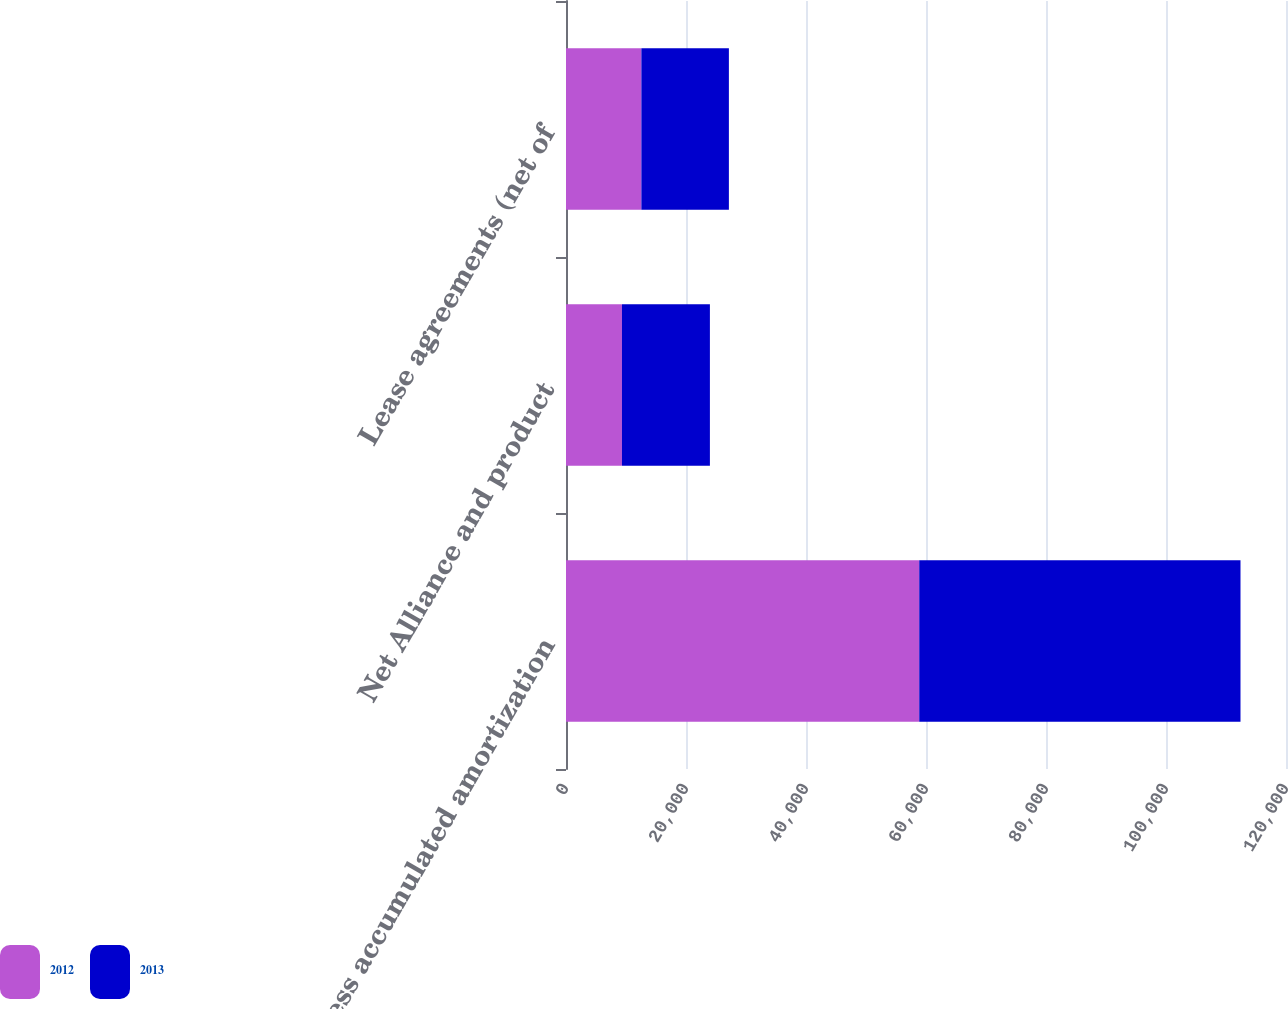Convert chart to OTSL. <chart><loc_0><loc_0><loc_500><loc_500><stacked_bar_chart><ecel><fcel>Less accumulated amortization<fcel>Net Alliance and product<fcel>Lease agreements (net of<nl><fcel>2012<fcel>58873<fcel>9327<fcel>12563<nl><fcel>2013<fcel>53543<fcel>14657<fcel>14585<nl></chart> 